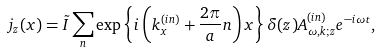<formula> <loc_0><loc_0><loc_500><loc_500>j _ { z } ( x ) = \tilde { I } \sum _ { n } \exp { \left \{ i \left ( k _ { x } ^ { ( i n ) } + \frac { 2 \pi } { a } n \right ) x \right \} } \, \delta ( z ) A _ { \omega , k ; z } ^ { ( i n ) } e ^ { - i \omega t } ,</formula> 